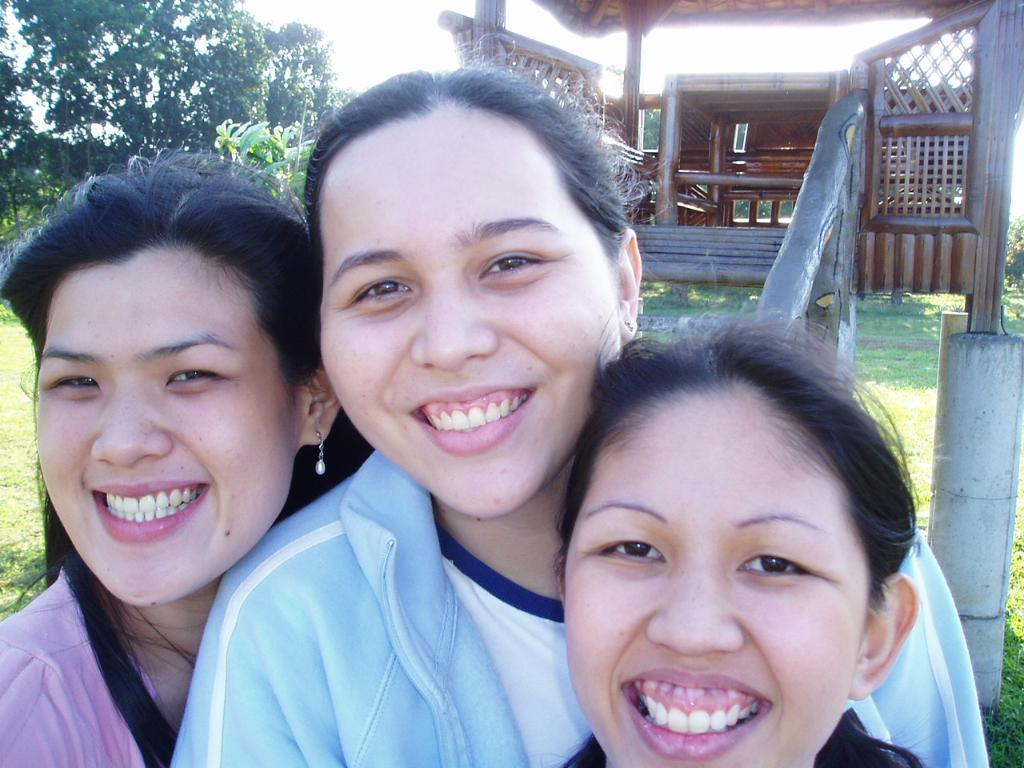What is the main subject of the image? There is a woman standing in the center of the image. What is the woman standing on? The woman is standing on the ground. What can be seen in the background of the image? There are trees, stairs, a table, and chairs in the background of the image. What type of beam is the carpenter using to build the structure at night in the image? There is no carpenter, beam, or structure being built at night in the image. The image features a woman standing in the center, with trees, stairs, a table, and chairs in the background. 